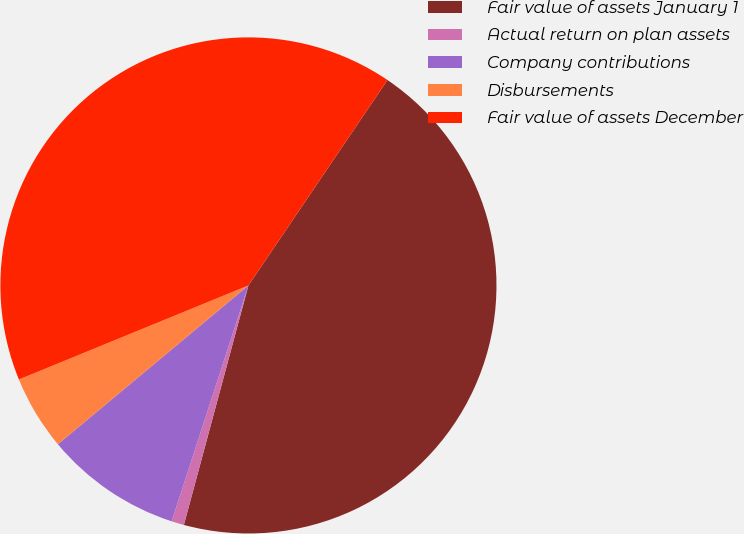<chart> <loc_0><loc_0><loc_500><loc_500><pie_chart><fcel>Fair value of assets January 1<fcel>Actual return on plan assets<fcel>Company contributions<fcel>Disbursements<fcel>Fair value of assets December<nl><fcel>44.72%<fcel>0.82%<fcel>8.93%<fcel>4.87%<fcel>40.66%<nl></chart> 